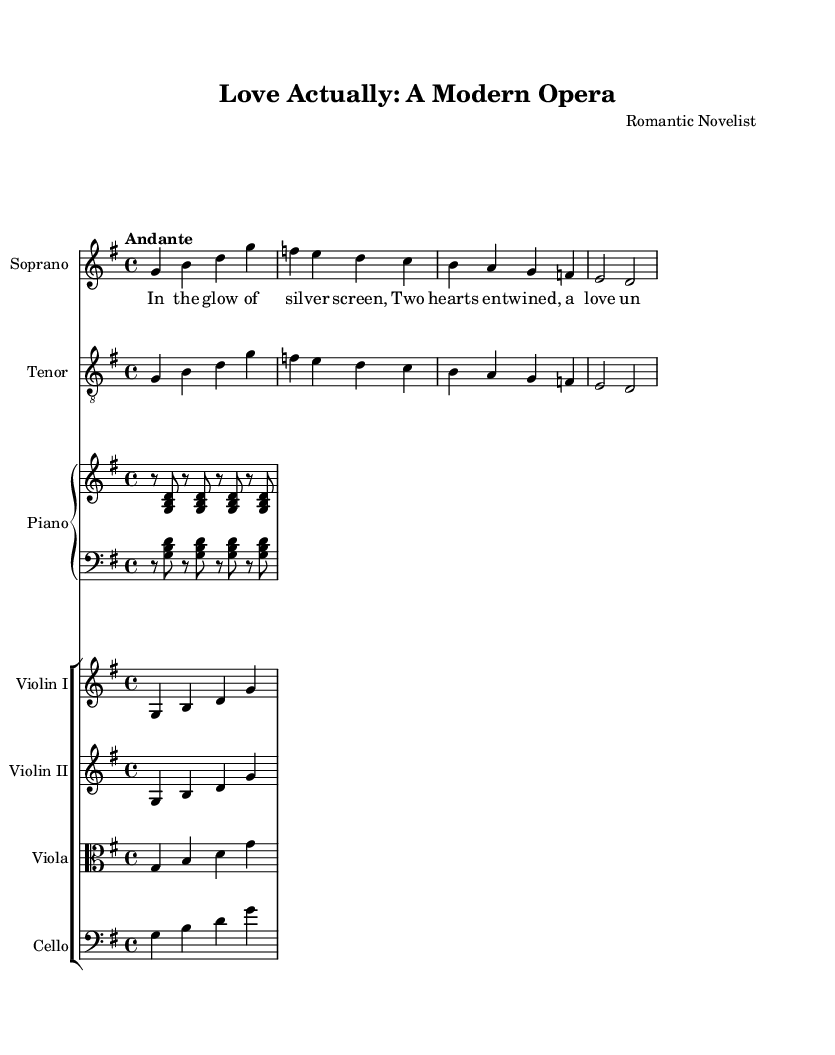What is the key signature of this music? The key signature is G major, which contains one sharp (F#). This is evident from the initial key signature denoted at the beginning of the piece.
Answer: G major What is the time signature of this music? The time signature is 4/4, as indicated at the beginning of the music. This means there are four beats per measure, and each beat is a quarter note.
Answer: 4/4 What is the tempo marking of the piece? The tempo marking is "Andante," which indicates a moderately slow speed for the piece. This is typically noted at the beginning of the music to guide the performers.
Answer: Andante How many measures are in the soprano part? The soprano part consists of four measures, which can be identified by counting the grouping of the notes and the vertical lines separating the measures in the score.
Answer: Four What is the lyric text for the soprano verse? The lyric text for the soprano verse is "In the glow of silver screen, Two hearts entwined, a love unseen." This can be found written below the corresponding notes for the soprano voice.
Answer: In the glow of silver screen, Two hearts entwined, a love unseen How does the tenor part compare to the soprano part? The tenor part is identical to the soprano part, both in melody and rhythm. This can be concluded by analyzing the notes written for each voice and noting that they are notated the same way across the score.
Answer: Identical What instruments are included in the scored orchestra? The orchestra includes piano, violin, viola, and cello. This can be determined by examining the staff groups and the instrument names listed at the beginning of each staff in the score.
Answer: Piano, violin, viola, cello 